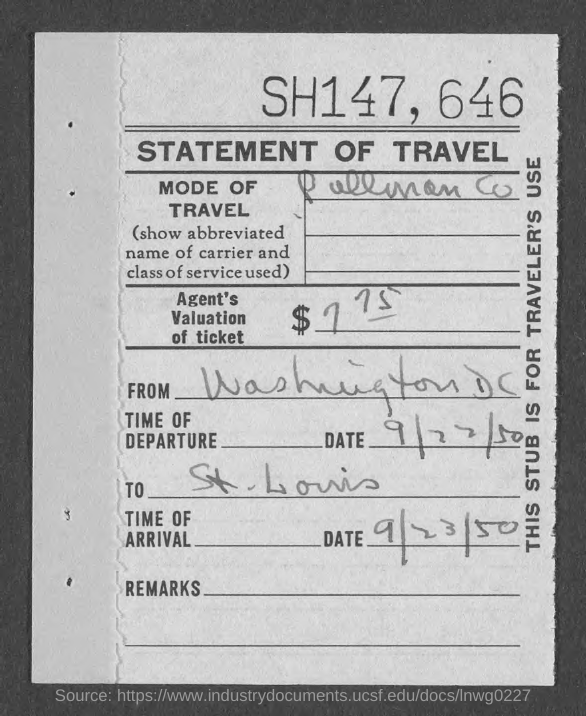Specify some key components in this picture. The date of arrival is September 23, 1950. 